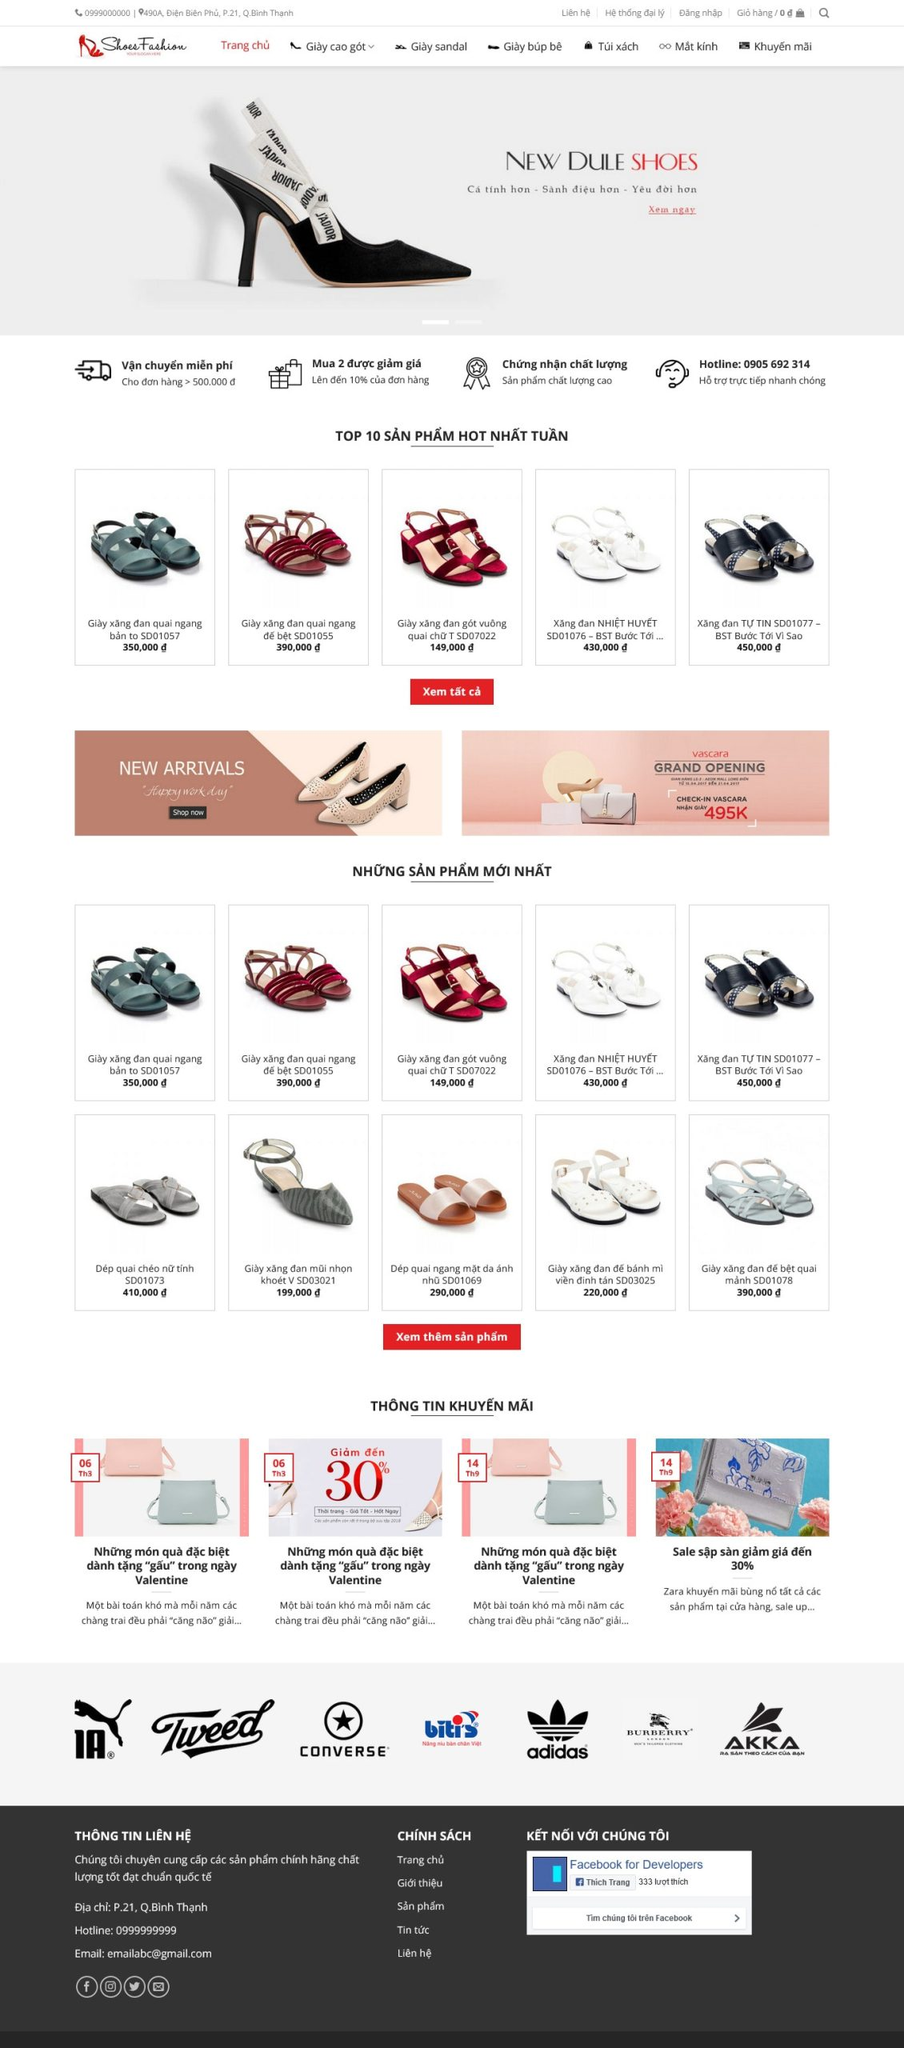Viết một bài viết giới thiệu giao diện website này của DPS MEDIA bao gồm ngành nghề, kiểu dáng, màu sắc, tính năng, bố cục,...Nhưng không nhắc lại liên kết hình ảnh trong bài viết.
 **Giới Thiệu Giao Diện Website DPS MEDIA**

Website của DPS MEDIA mang đến một trải nghiệm mua sắm trực tuyến chuyên nghiệp và hiện đại, tập trung vào ngành thời trang, đặc biệt là các sản phẩm giày dép. Dưới đây là một số đặc điểm nổi bật của giao diện website:

**1. Ngành Nghề:**
Website chuyên cung cấp các sản phẩm thời trang giày dép bao gồm giày cao gót, giày sandal, giày búp bê, cùng với các phụ kiện thời trang như túi xách và mắt kính.

**2. Kiểu Dáng và Màu Sắc:**
Giao diện website sử dụng tông màu trắng làm chủ đạo, kết hợp với các điểm nhấn màu đỏ và đen, tạo nên sự thanh lịch và sang trọng. Các sản phẩm được trình bày rõ ràng với hình ảnh sắc nét, giúp khách hàng dễ dàng quan sát chi tiết.

**3. Tính Năng:**
- **Vận chuyển miễn phí:** Cho đơn hàng từ 500.000đ trở lên.
- **Chương trình khuyến mãi:** Giảm giá khi mua 2 sản phẩm và chứng nhận chất lượng sản phẩm.
- **Hotline hỗ trợ:** Hỗ trợ trực tiếp nhanh chóng qua số điện thoại hiển thị rõ ràng.

**4. Bố Cục:**
- **Thanh Menu:** Gồm các danh mục chính như Trang chủ, Giày cao gót, Giày sandal, Giày búp bê, Túi xách, Mắt kính, Khuyến mãi.
- **Banner chính:** Hiển thị sản phẩm mới nhất cùng với slogan ấn tượng.
- **Danh sách sản phẩm hot nhất tuần:** Các sản phẩm bán chạy được sắp xếp ngay dưới banner chính để khách hàng dễ dàng tiếp cận.
- **Sản phẩm mới nhất:** Hiển thị các sản phẩm mới về, giúp khách hàng cập nhật xu hướng thời trang mới nhất.
- **Thông tin khuyến mãi:** Cung cấp các chương trình giảm giá và quà tặng đặc biệt.

**5. Footer:**
- **Thông tin liên hệ:** Bao gồm địa chỉ, hotline và email.
- **Chính sách:** Liên kết đến các trang chính sách của cửa hàng như chính sách giao hàng, đổi trả.
- **Kết nối mạng xã hội:** Liên kết đến trang Facebook và các nền tảng mạng xã hội khác.

Giao diện của website DPS MEDIA không chỉ dễ sử dụng mà còn tạo cảm giác thân thiện, chuyên nghiệp, giúp khách hàng có trải nghiệm mua sắm trực tuyến tối ưu. 